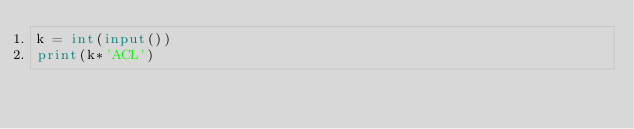<code> <loc_0><loc_0><loc_500><loc_500><_Python_>k = int(input())
print(k*'ACL')</code> 